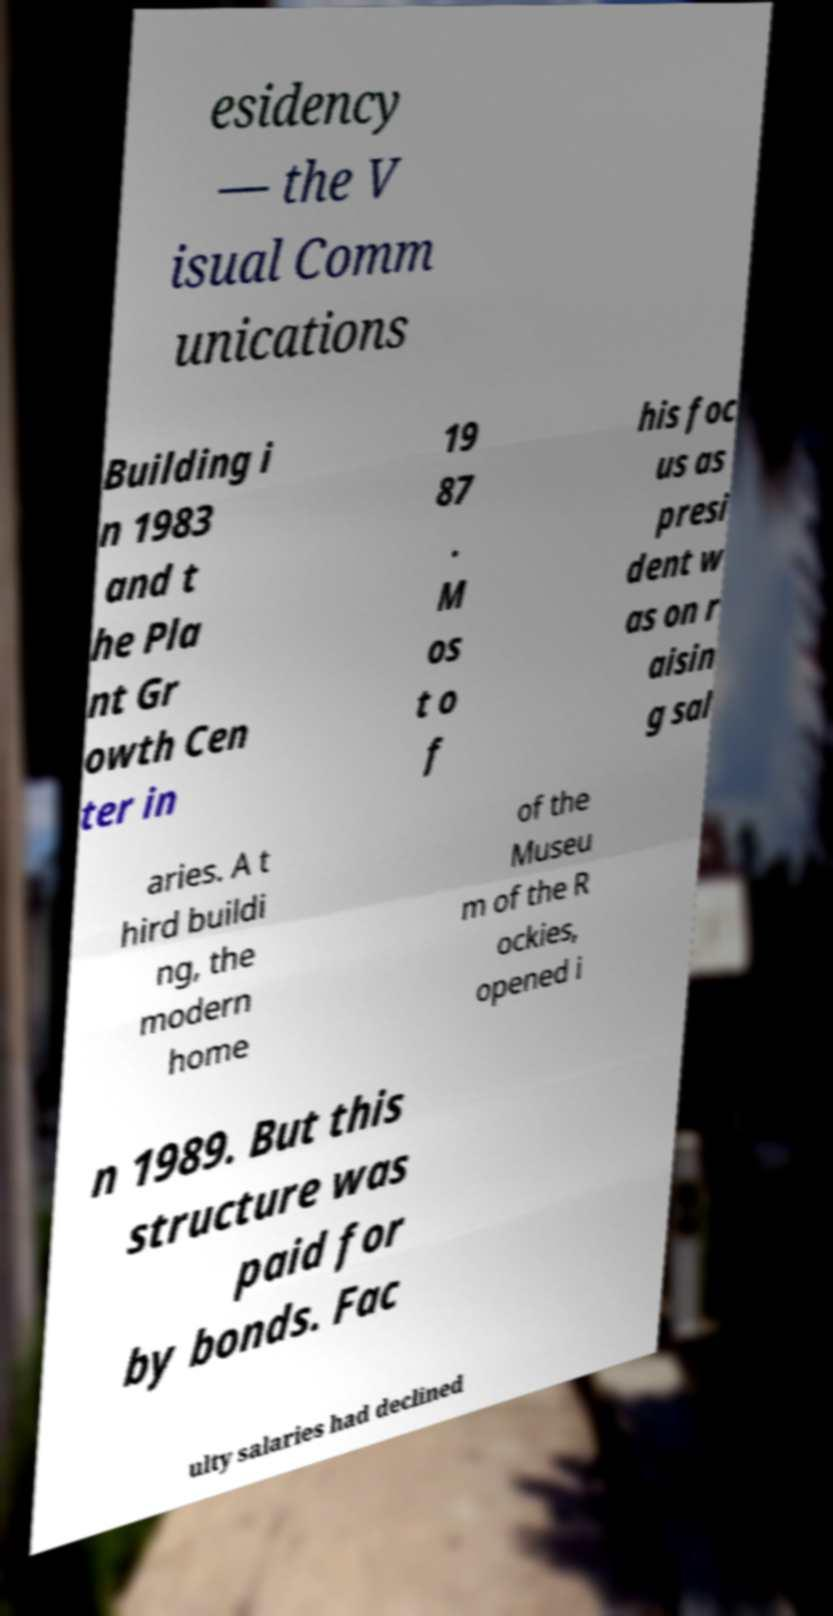Could you assist in decoding the text presented in this image and type it out clearly? esidency — the V isual Comm unications Building i n 1983 and t he Pla nt Gr owth Cen ter in 19 87 . M os t o f his foc us as presi dent w as on r aisin g sal aries. A t hird buildi ng, the modern home of the Museu m of the R ockies, opened i n 1989. But this structure was paid for by bonds. Fac ulty salaries had declined 